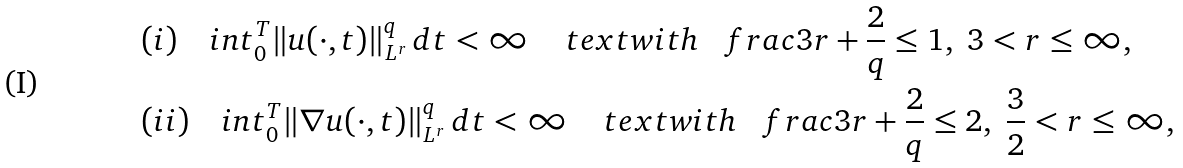Convert formula to latex. <formula><loc_0><loc_0><loc_500><loc_500>& ( i ) \quad i n t _ { 0 } ^ { T } \| u ( \cdot , t ) \| _ { L ^ { r } } ^ { q } \, d t < \infty \ \ \ \ t e x t { w i t h } \ \ \ f r a c { 3 } { r } + \frac { 2 } { q } \leq 1 , \ 3 < r \leq \infty , \\ & ( i i ) \quad i n t _ { 0 } ^ { T } \| \nabla u ( \cdot , t ) \| _ { L ^ { r } } ^ { q } \, d t < \infty \ \ \ \ t e x t { w i t h } \ \ \ f r a c { 3 } { r } + \frac { 2 } { q } \leq 2 , \ \frac { 3 } { 2 } < r \leq \infty ,</formula> 